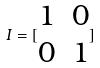Convert formula to latex. <formula><loc_0><loc_0><loc_500><loc_500>I = [ \begin{matrix} 1 & 0 \\ 0 & 1 \end{matrix} ]</formula> 